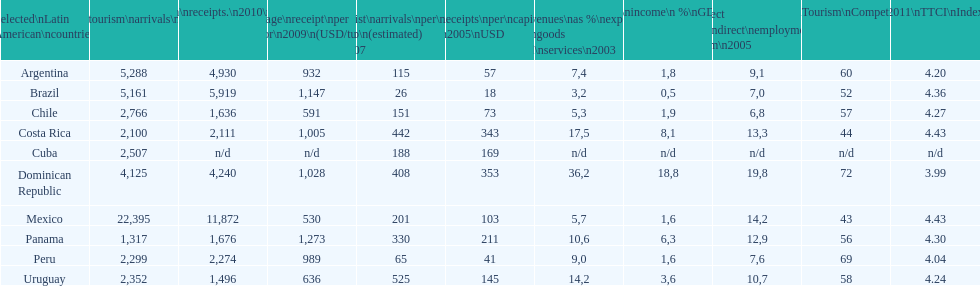What is the name of the country that received the most foreign tourism visits in 2010? Mexico. 